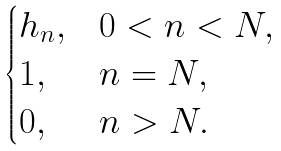<formula> <loc_0><loc_0><loc_500><loc_500>\begin{cases} h _ { n } , & 0 < n < N , \\ 1 , & n = N , \\ 0 , & n > N . \end{cases}</formula> 